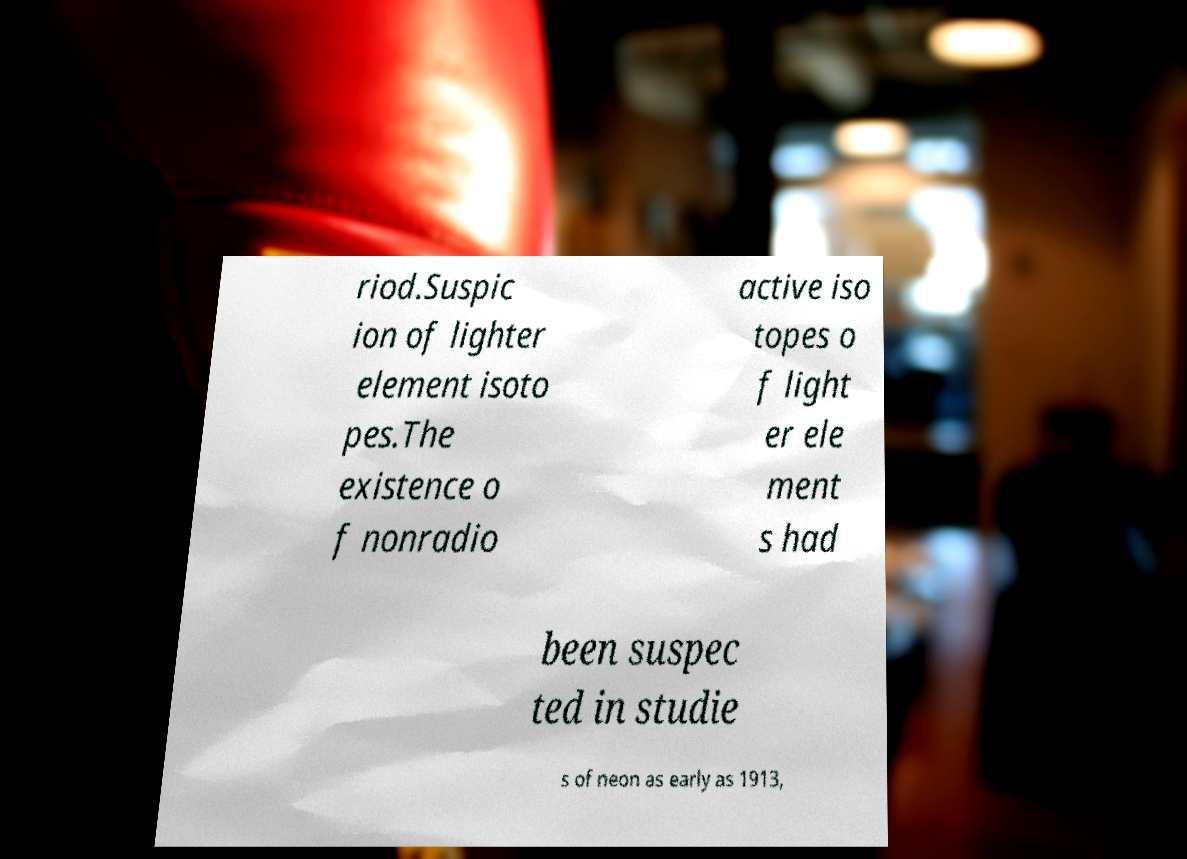Please read and relay the text visible in this image. What does it say? riod.Suspic ion of lighter element isoto pes.The existence o f nonradio active iso topes o f light er ele ment s had been suspec ted in studie s of neon as early as 1913, 